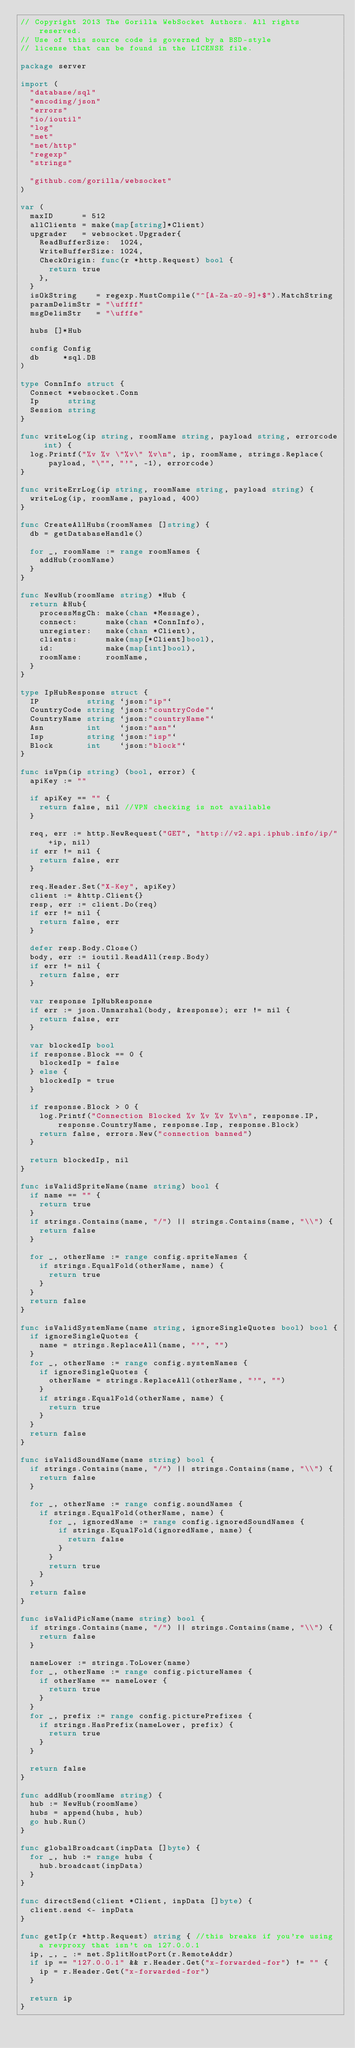Convert code to text. <code><loc_0><loc_0><loc_500><loc_500><_Go_>// Copyright 2013 The Gorilla WebSocket Authors. All rights reserved.
// Use of this source code is governed by a BSD-style
// license that can be found in the LICENSE file.

package server

import (
	"database/sql"
	"encoding/json"
	"errors"
	"io/ioutil"
	"log"
	"net"
	"net/http"
	"regexp"
	"strings"

	"github.com/gorilla/websocket"
)

var (
	maxID      = 512
	allClients = make(map[string]*Client)
	upgrader   = websocket.Upgrader{
		ReadBufferSize:  1024,
		WriteBufferSize: 1024,
		CheckOrigin: func(r *http.Request) bool {
			return true
		},
	}
	isOkString    = regexp.MustCompile("^[A-Za-z0-9]+$").MatchString
	paramDelimStr = "\uffff"
	msgDelimStr   = "\ufffe"

	hubs []*Hub

	config Config
	db     *sql.DB
)

type ConnInfo struct {
	Connect *websocket.Conn
	Ip      string
	Session string
}

func writeLog(ip string, roomName string, payload string, errorcode int) {
	log.Printf("%v %v \"%v\" %v\n", ip, roomName, strings.Replace(payload, "\"", "'", -1), errorcode)
}

func writeErrLog(ip string, roomName string, payload string) {
	writeLog(ip, roomName, payload, 400)
}

func CreateAllHubs(roomNames []string) {
	db = getDatabaseHandle()

	for _, roomName := range roomNames {
		addHub(roomName)
	}
}

func NewHub(roomName string) *Hub {
	return &Hub{
		processMsgCh: make(chan *Message),
		connect:      make(chan *ConnInfo),
		unregister:   make(chan *Client),
		clients:      make(map[*Client]bool),
		id:           make(map[int]bool),
		roomName:     roomName,
	}
}

type IpHubResponse struct {
	IP          string `json:"ip"`
	CountryCode string `json:"countryCode"`
	CountryName string `json:"countryName"`
	Asn         int    `json:"asn"`
	Isp         string `json:"isp"`
	Block       int    `json:"block"`
}

func isVpn(ip string) (bool, error) {
	apiKey := ""

	if apiKey == "" {
		return false, nil //VPN checking is not available
	}

	req, err := http.NewRequest("GET", "http://v2.api.iphub.info/ip/"+ip, nil)
	if err != nil {
		return false, err
	}

	req.Header.Set("X-Key", apiKey)
	client := &http.Client{}
	resp, err := client.Do(req)
	if err != nil {
		return false, err
	}

	defer resp.Body.Close()
	body, err := ioutil.ReadAll(resp.Body)
	if err != nil {
		return false, err
	}

	var response IpHubResponse
	if err := json.Unmarshal(body, &response); err != nil {
		return false, err
	}

	var blockedIp bool
	if response.Block == 0 {
		blockedIp = false
	} else {
		blockedIp = true
	}

	if response.Block > 0 {
		log.Printf("Connection Blocked %v %v %v %v\n", response.IP, response.CountryName, response.Isp, response.Block)
		return false, errors.New("connection banned")
	}

	return blockedIp, nil
}

func isValidSpriteName(name string) bool {
	if name == "" {
		return true
	}
	if strings.Contains(name, "/") || strings.Contains(name, "\\") {
		return false
	}

	for _, otherName := range config.spriteNames {
		if strings.EqualFold(otherName, name) {
			return true
		}
	}
	return false
}

func isValidSystemName(name string, ignoreSingleQuotes bool) bool {
	if ignoreSingleQuotes {
		name = strings.ReplaceAll(name, "'", "")
	}
	for _, otherName := range config.systemNames {
		if ignoreSingleQuotes {
			otherName = strings.ReplaceAll(otherName, "'", "")
		}
		if strings.EqualFold(otherName, name) {
			return true
		}
	}
	return false
}

func isValidSoundName(name string) bool {
	if strings.Contains(name, "/") || strings.Contains(name, "\\") {
		return false
	}

	for _, otherName := range config.soundNames {
		if strings.EqualFold(otherName, name) {
			for _, ignoredName := range config.ignoredSoundNames {
				if strings.EqualFold(ignoredName, name) {
					return false
				}
			}
			return true
		}
	}
	return false
}

func isValidPicName(name string) bool {
	if strings.Contains(name, "/") || strings.Contains(name, "\\") {
		return false
	}

	nameLower := strings.ToLower(name)
	for _, otherName := range config.pictureNames {
		if otherName == nameLower {
			return true
		}
	}
	for _, prefix := range config.picturePrefixes {
		if strings.HasPrefix(nameLower, prefix) {
			return true
		}
	}

	return false
}

func addHub(roomName string) {
	hub := NewHub(roomName)
	hubs = append(hubs, hub)
	go hub.Run()
}

func globalBroadcast(inpData []byte) {
	for _, hub := range hubs {
		hub.broadcast(inpData)
	}
}

func directSend(client *Client, inpData []byte) {
	client.send <- inpData
}

func getIp(r *http.Request) string { //this breaks if you're using a revproxy that isn't on 127.0.0.1
	ip, _, _ := net.SplitHostPort(r.RemoteAddr)
	if ip == "127.0.0.1" && r.Header.Get("x-forwarded-for") != "" {
		ip = r.Header.Get("x-forwarded-for")
	}

	return ip
}
</code> 